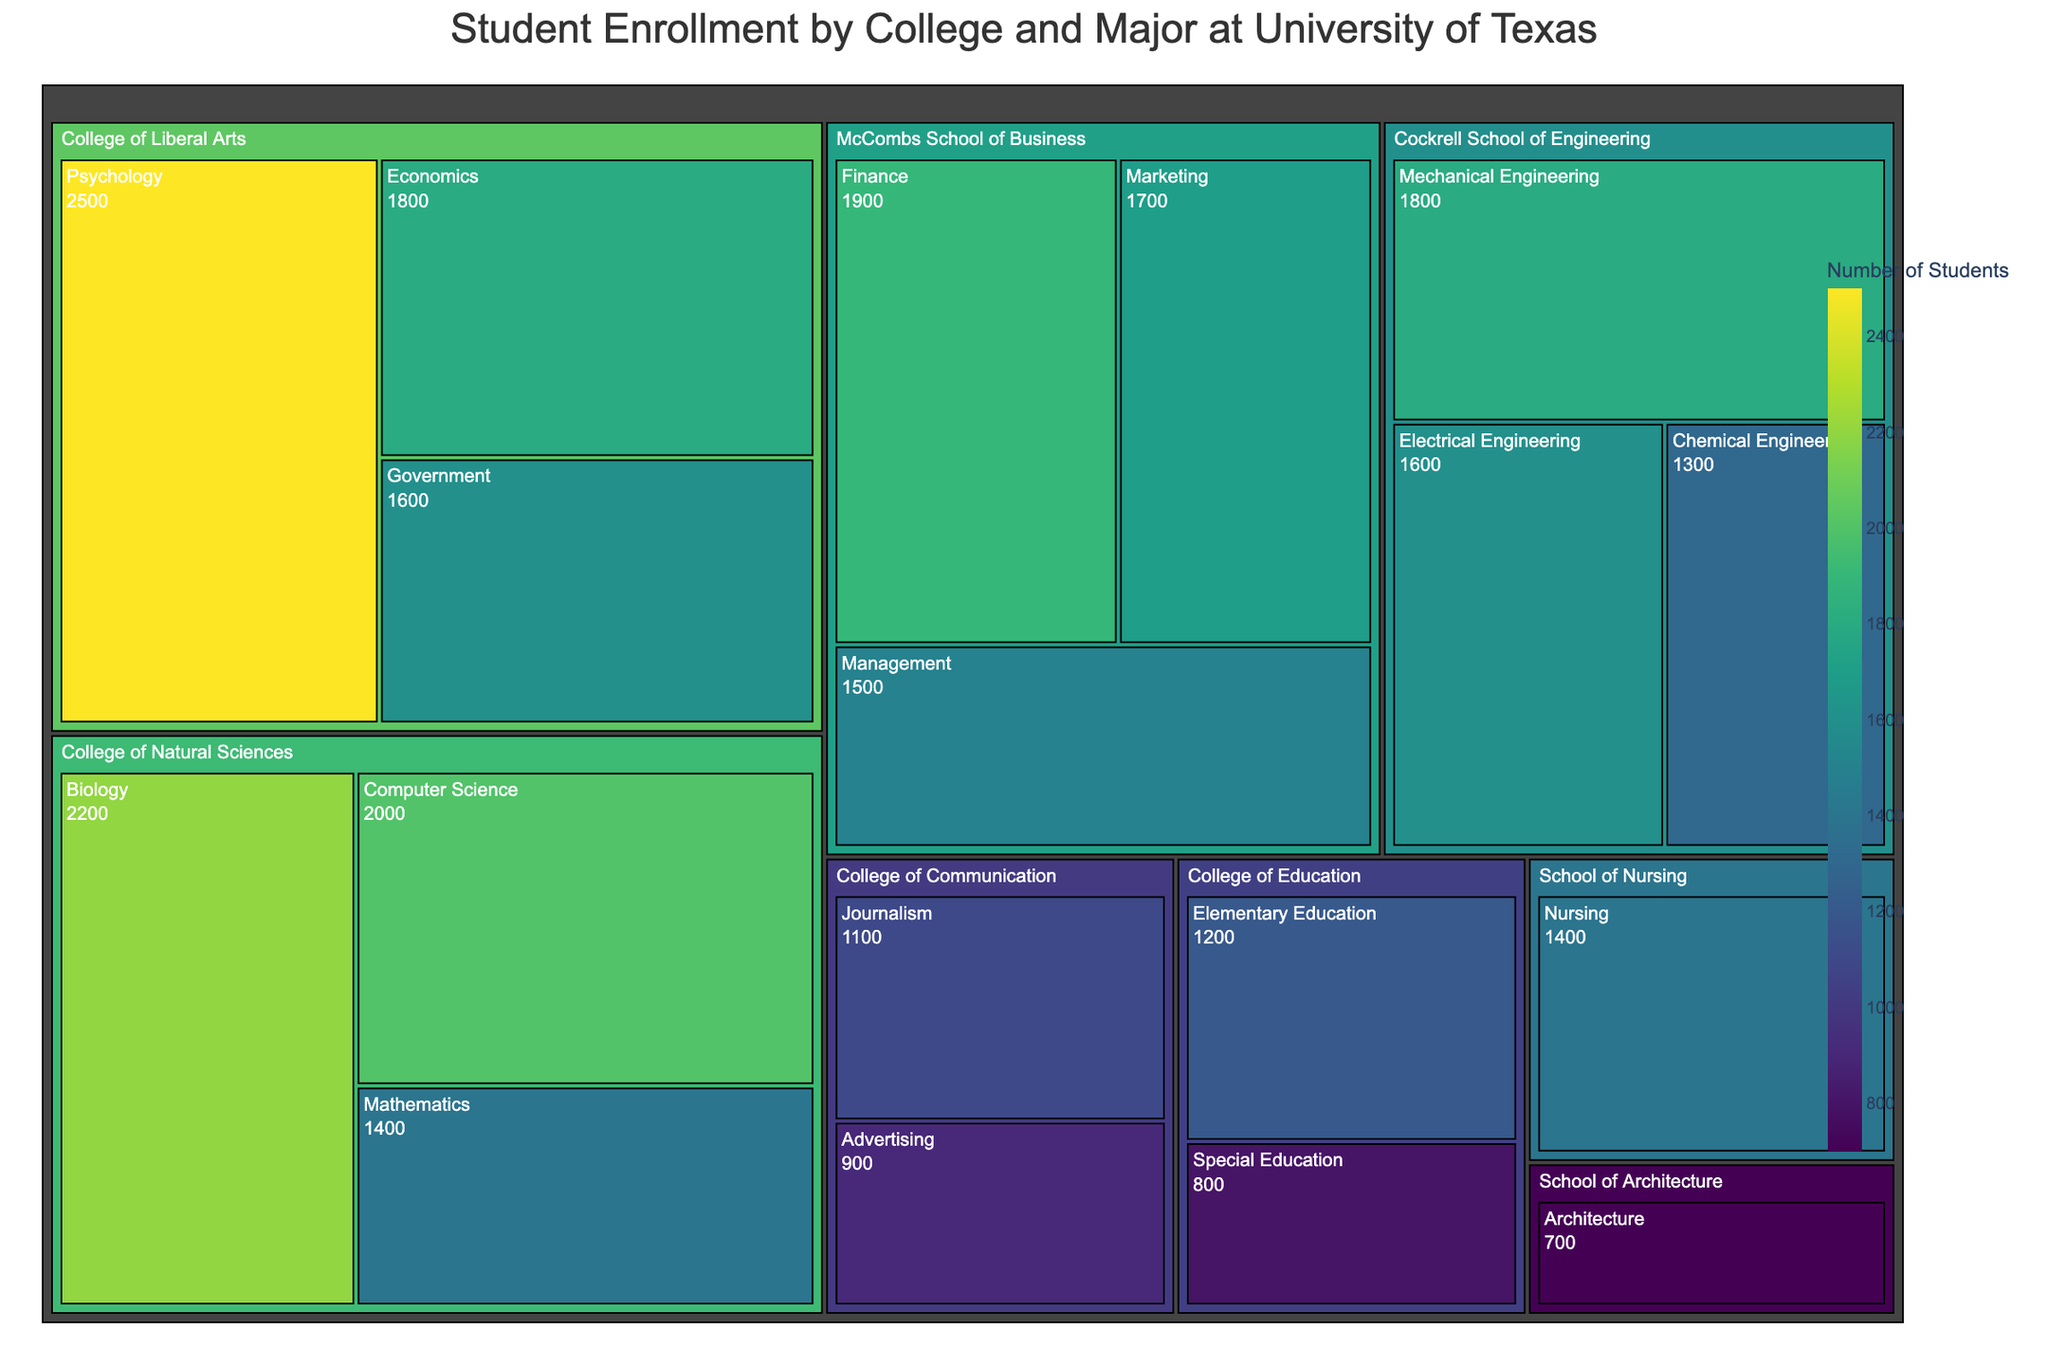How many students are enrolled in the College of Communication? The College of Communication includes Journalism (1100 students) and Advertising (900 students). Summing these gives 1100 + 900 = 2000 students.
Answer: 2000 Which major has the highest student enrollment in the College of Natural Sciences? The majors in the College of Natural Sciences are Biology (2200 students), Computer Science (2000 students), and Mathematics (1400 students). The highest enrollment is in Biology with 2200 students.
Answer: Biology Compare the student enrollments in Finance and Marketing in the McCombs School of Business. Which major has more students and by how much? Finance has 1900 students, and Marketing has 1700 students. The difference is 1900 - 1700 = 200 students. Finance has 200 more students than Marketing.
Answer: Finance by 200 What is the total student enrollment in the McCombs School of Business? The McCombs School of Business has Finance (1900 students), Marketing (1700 students), and Management (1500 students). Summing these gives 1900 + 1700 + 1500 = 5100 students.
Answer: 5100 Which has a larger student enrollment: the School of Nursing or the School of Architecture? The School of Nursing has 1400 students, while the School of Architecture has 700 students. 1400 is greater than 700, so the School of Nursing has a larger enrollment.
Answer: School of Nursing What is the average student enrollment per major in the Cockrell School of Engineering? The Cockrell School of Engineering has Mechanical Engineering (1800 students), Electrical Engineering (1600 students), and Chemical Engineering (1300 students). Summing these gives 1800 + 1600 + 1300 = 4700 students. Dividing by 3 majors gives 4700 / 3 = approximately 1567 students.
Answer: Approximately 1567 Identify the major with the lowest enrollment across the entire university. The majors with their respective enrollments are examined, and the lowest enrollment is in Architecture with 700 students.
Answer: Architecture Which college has the most students enrolled when adding up all its majors? The colleges and their total enrollments are: College of Liberal Arts (2500 + 1800 + 1600 = 5900), College of Natural Sciences (2200 + 2000 + 1400 = 5600), McCombs School of Business (5100), Cockrell School of Engineering (4700), College of Education (2000), School of Nursing (1400), College of Communication (2000), and School of Architecture (700). The College of Liberal Arts has the highest total with 5900 students.
Answer: College of Liberal Arts How does the student enrollment in Economics compare to Government within the College of Liberal Arts? Economics has 1800 students and Government has 1600 students. 1800 - 1600 = 200, so Economics has 200 more students than Government.
Answer: Economics by 200 